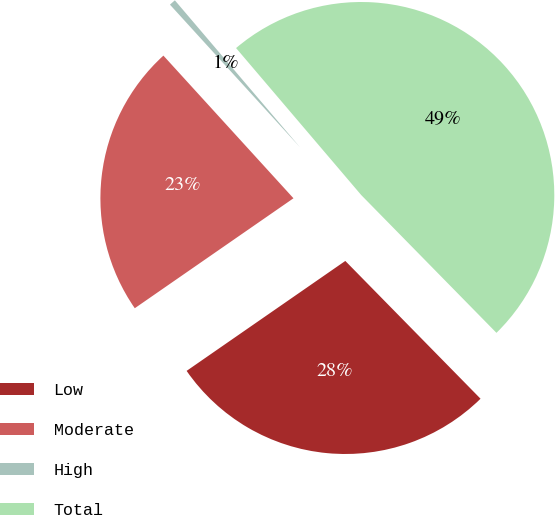Convert chart to OTSL. <chart><loc_0><loc_0><loc_500><loc_500><pie_chart><fcel>Low<fcel>Moderate<fcel>High<fcel>Total<nl><fcel>27.71%<fcel>22.88%<fcel>0.54%<fcel>48.88%<nl></chart> 